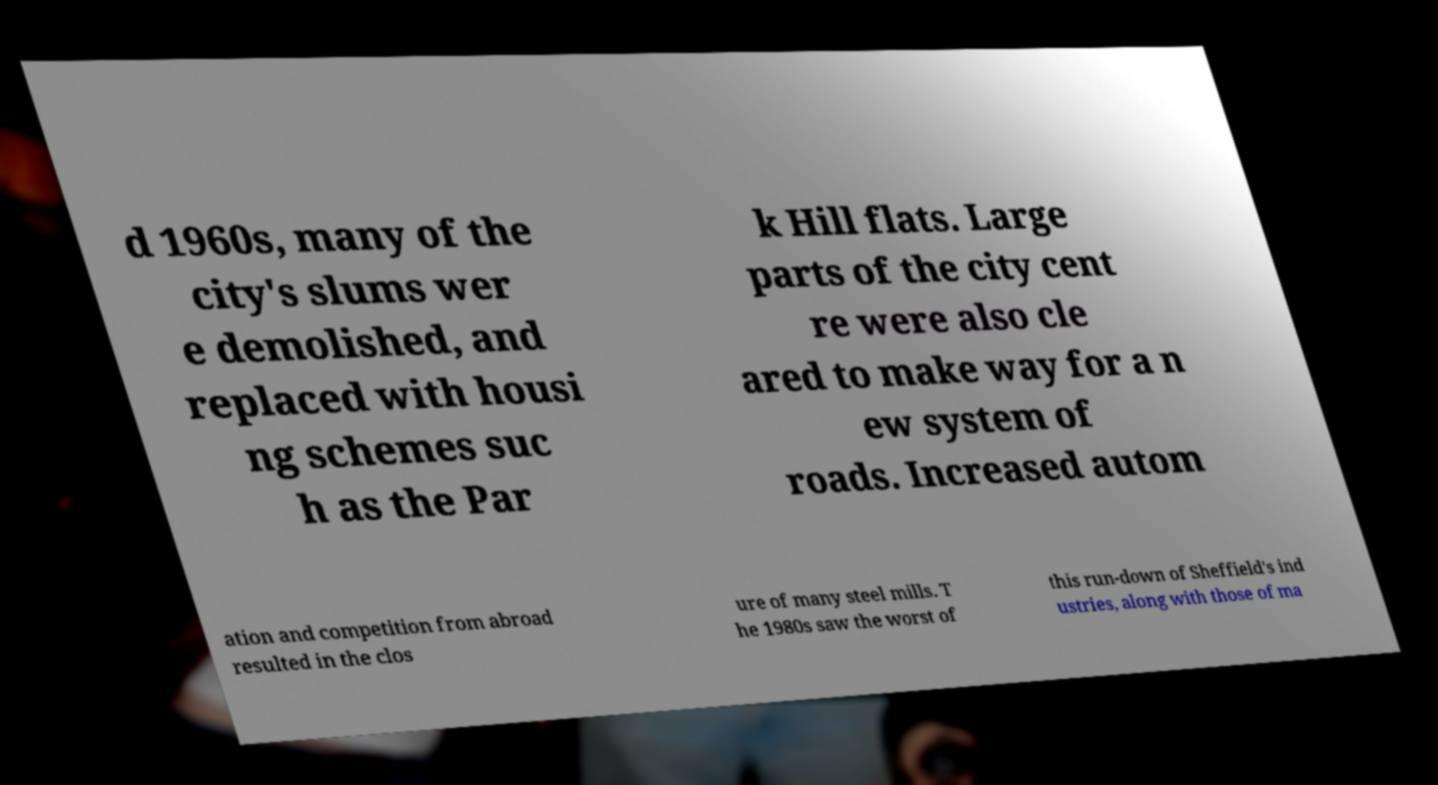I need the written content from this picture converted into text. Can you do that? d 1960s, many of the city's slums wer e demolished, and replaced with housi ng schemes suc h as the Par k Hill flats. Large parts of the city cent re were also cle ared to make way for a n ew system of roads. Increased autom ation and competition from abroad resulted in the clos ure of many steel mills. T he 1980s saw the worst of this run-down of Sheffield's ind ustries, along with those of ma 